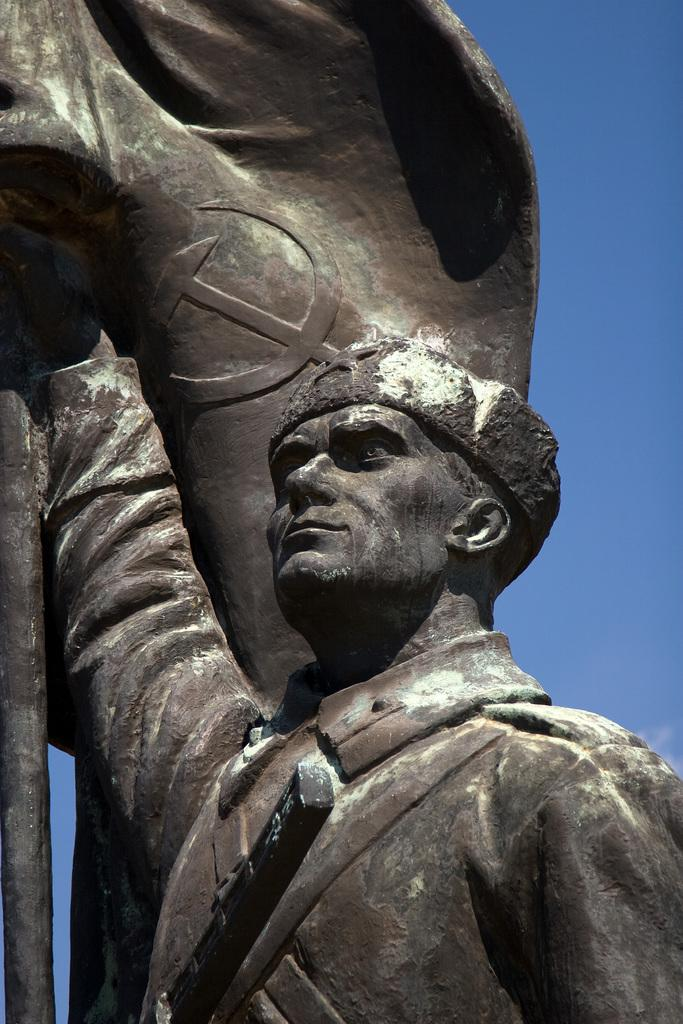What type of artwork is shown in the image? The image is a sculpture. What subject matter is depicted in the sculpture? The sculpture depicts a man. What is the man holding in the sculpture? The man is holding a flag. What is the view like from the man's throat in the sculpture? There is no view from the man's throat in the sculpture, as it is a static artwork and not a living being. 